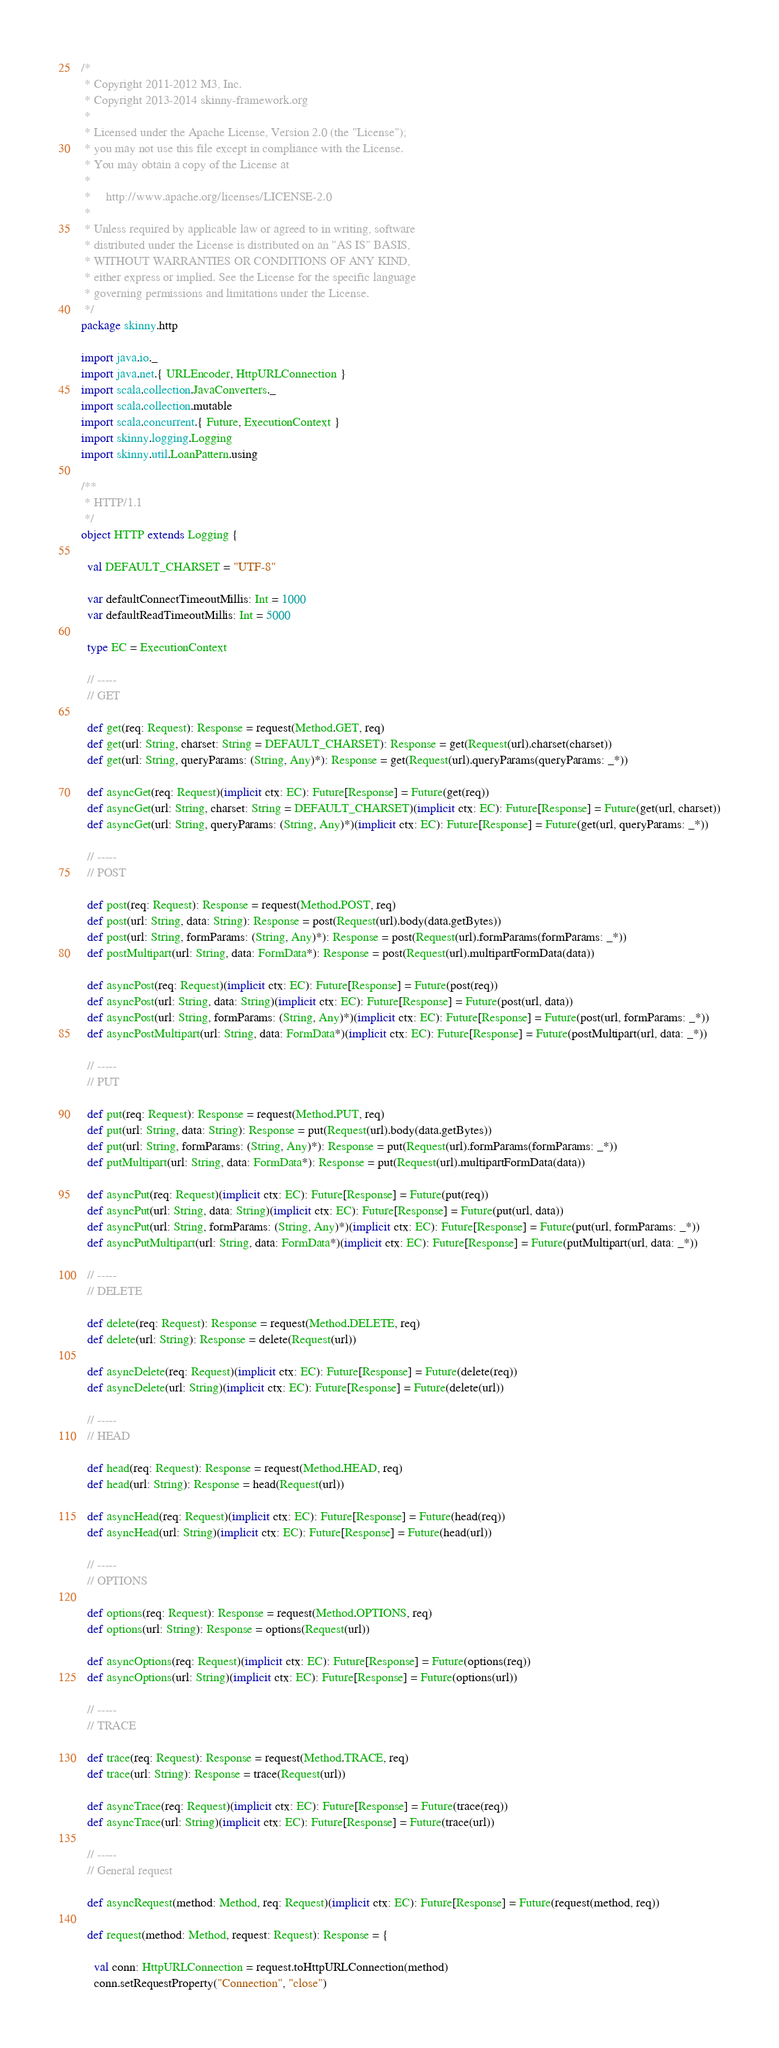<code> <loc_0><loc_0><loc_500><loc_500><_Scala_>/*
 * Copyright 2011-2012 M3, Inc.
 * Copyright 2013-2014 skinny-framework.org
 *
 * Licensed under the Apache License, Version 2.0 (the "License");
 * you may not use this file except in compliance with the License.
 * You may obtain a copy of the License at
 *
 *     http://www.apache.org/licenses/LICENSE-2.0
 *
 * Unless required by applicable law or agreed to in writing, software
 * distributed under the License is distributed on an "AS IS" BASIS,
 * WITHOUT WARRANTIES OR CONDITIONS OF ANY KIND,
 * either express or implied. See the License for the specific language
 * governing permissions and limitations under the License.
 */
package skinny.http

import java.io._
import java.net.{ URLEncoder, HttpURLConnection }
import scala.collection.JavaConverters._
import scala.collection.mutable
import scala.concurrent.{ Future, ExecutionContext }
import skinny.logging.Logging
import skinny.util.LoanPattern.using

/**
 * HTTP/1.1
 */
object HTTP extends Logging {

  val DEFAULT_CHARSET = "UTF-8"

  var defaultConnectTimeoutMillis: Int = 1000
  var defaultReadTimeoutMillis: Int = 5000

  type EC = ExecutionContext

  // -----
  // GET

  def get(req: Request): Response = request(Method.GET, req)
  def get(url: String, charset: String = DEFAULT_CHARSET): Response = get(Request(url).charset(charset))
  def get(url: String, queryParams: (String, Any)*): Response = get(Request(url).queryParams(queryParams: _*))

  def asyncGet(req: Request)(implicit ctx: EC): Future[Response] = Future(get(req))
  def asyncGet(url: String, charset: String = DEFAULT_CHARSET)(implicit ctx: EC): Future[Response] = Future(get(url, charset))
  def asyncGet(url: String, queryParams: (String, Any)*)(implicit ctx: EC): Future[Response] = Future(get(url, queryParams: _*))

  // -----
  // POST

  def post(req: Request): Response = request(Method.POST, req)
  def post(url: String, data: String): Response = post(Request(url).body(data.getBytes))
  def post(url: String, formParams: (String, Any)*): Response = post(Request(url).formParams(formParams: _*))
  def postMultipart(url: String, data: FormData*): Response = post(Request(url).multipartFormData(data))

  def asyncPost(req: Request)(implicit ctx: EC): Future[Response] = Future(post(req))
  def asyncPost(url: String, data: String)(implicit ctx: EC): Future[Response] = Future(post(url, data))
  def asyncPost(url: String, formParams: (String, Any)*)(implicit ctx: EC): Future[Response] = Future(post(url, formParams: _*))
  def asyncPostMultipart(url: String, data: FormData*)(implicit ctx: EC): Future[Response] = Future(postMultipart(url, data: _*))

  // -----
  // PUT

  def put(req: Request): Response = request(Method.PUT, req)
  def put(url: String, data: String): Response = put(Request(url).body(data.getBytes))
  def put(url: String, formParams: (String, Any)*): Response = put(Request(url).formParams(formParams: _*))
  def putMultipart(url: String, data: FormData*): Response = put(Request(url).multipartFormData(data))

  def asyncPut(req: Request)(implicit ctx: EC): Future[Response] = Future(put(req))
  def asyncPut(url: String, data: String)(implicit ctx: EC): Future[Response] = Future(put(url, data))
  def asyncPut(url: String, formParams: (String, Any)*)(implicit ctx: EC): Future[Response] = Future(put(url, formParams: _*))
  def asyncPutMultipart(url: String, data: FormData*)(implicit ctx: EC): Future[Response] = Future(putMultipart(url, data: _*))

  // -----
  // DELETE

  def delete(req: Request): Response = request(Method.DELETE, req)
  def delete(url: String): Response = delete(Request(url))

  def asyncDelete(req: Request)(implicit ctx: EC): Future[Response] = Future(delete(req))
  def asyncDelete(url: String)(implicit ctx: EC): Future[Response] = Future(delete(url))

  // -----
  // HEAD

  def head(req: Request): Response = request(Method.HEAD, req)
  def head(url: String): Response = head(Request(url))

  def asyncHead(req: Request)(implicit ctx: EC): Future[Response] = Future(head(req))
  def asyncHead(url: String)(implicit ctx: EC): Future[Response] = Future(head(url))

  // -----
  // OPTIONS

  def options(req: Request): Response = request(Method.OPTIONS, req)
  def options(url: String): Response = options(Request(url))

  def asyncOptions(req: Request)(implicit ctx: EC): Future[Response] = Future(options(req))
  def asyncOptions(url: String)(implicit ctx: EC): Future[Response] = Future(options(url))

  // -----
  // TRACE

  def trace(req: Request): Response = request(Method.TRACE, req)
  def trace(url: String): Response = trace(Request(url))

  def asyncTrace(req: Request)(implicit ctx: EC): Future[Response] = Future(trace(req))
  def asyncTrace(url: String)(implicit ctx: EC): Future[Response] = Future(trace(url))

  // -----
  // General request

  def asyncRequest(method: Method, req: Request)(implicit ctx: EC): Future[Response] = Future(request(method, req))

  def request(method: Method, request: Request): Response = {

    val conn: HttpURLConnection = request.toHttpURLConnection(method)
    conn.setRequestProperty("Connection", "close")</code> 